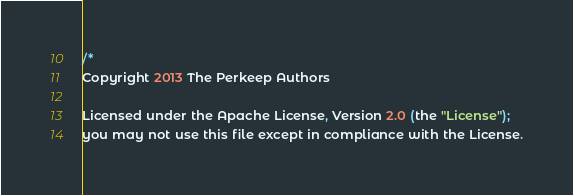Convert code to text. <code><loc_0><loc_0><loc_500><loc_500><_Go_>/*
Copyright 2013 The Perkeep Authors

Licensed under the Apache License, Version 2.0 (the "License");
you may not use this file except in compliance with the License.</code> 